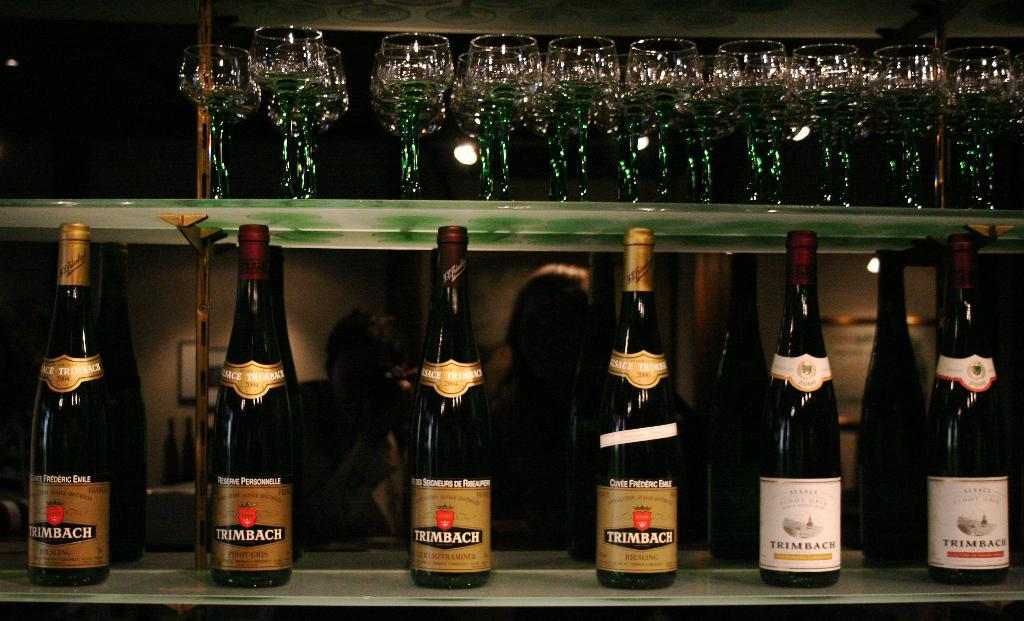Provide a one-sentence caption for the provided image. A row of Trimbach wine bottles are lined up under a shelf of glasses. 